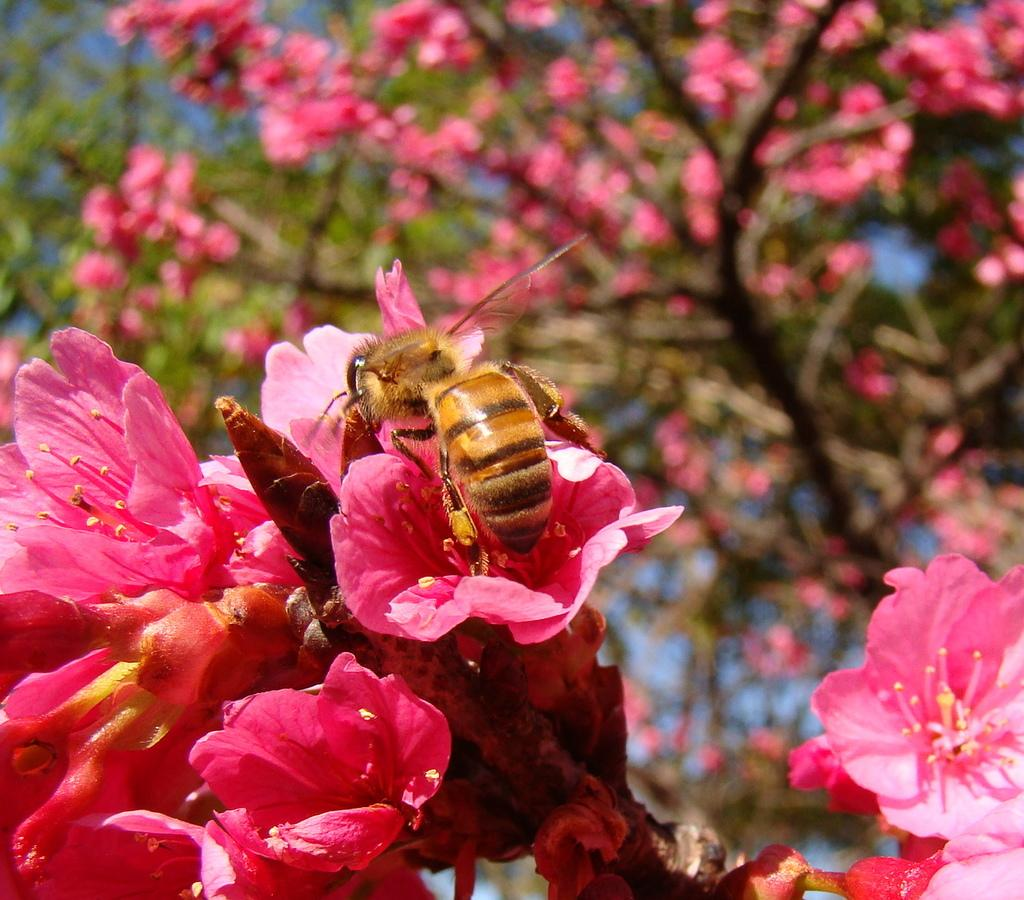What is on the flowers of the tree in the image? There is a bee on the flowers of a tree in the image. What can be seen in the background of the image? There are trees and flowers in the background of the image. What type of shirt is the bee wearing in the image? Bees do not wear shirts, and there is no shirt present in the image. 